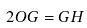<formula> <loc_0><loc_0><loc_500><loc_500>2 O G = G H</formula> 